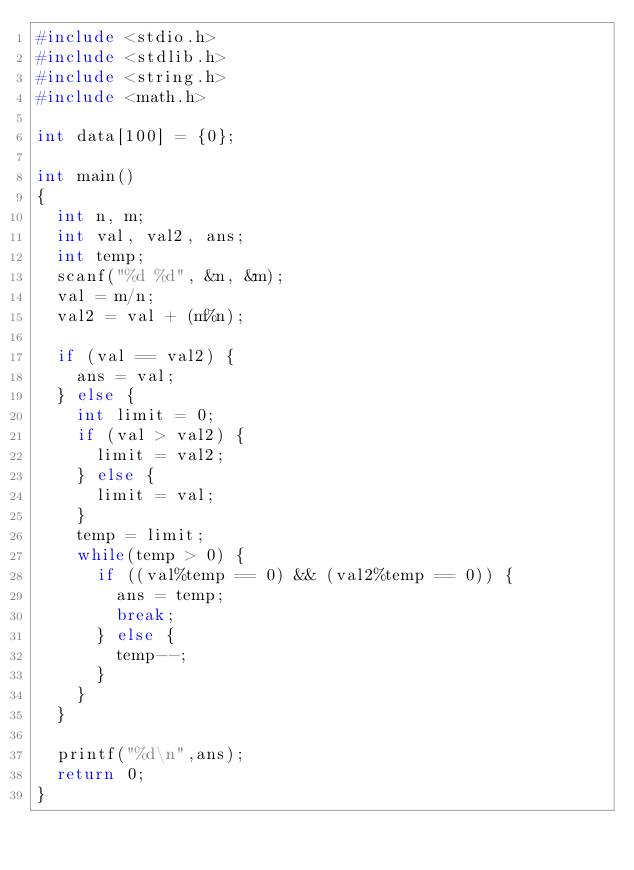Convert code to text. <code><loc_0><loc_0><loc_500><loc_500><_C_>#include <stdio.h>
#include <stdlib.h>
#include <string.h>
#include <math.h>

int data[100] = {0};

int main()
{
	int n, m;
	int val, val2, ans;
	int temp;
	scanf("%d %d", &n, &m);
	val = m/n;
	val2 = val + (m%n);

	if (val == val2) {
		ans = val;
	} else {
		int limit = 0;
		if (val > val2) {
			limit = val2;
		} else {
			limit = val;
		}
		temp = limit;
		while(temp > 0) {
			if ((val%temp == 0) && (val2%temp == 0)) {
				ans = temp;
				break;
			} else {
				temp--;
			}
		}
	}

	printf("%d\n",ans);
	return 0;
}
</code> 